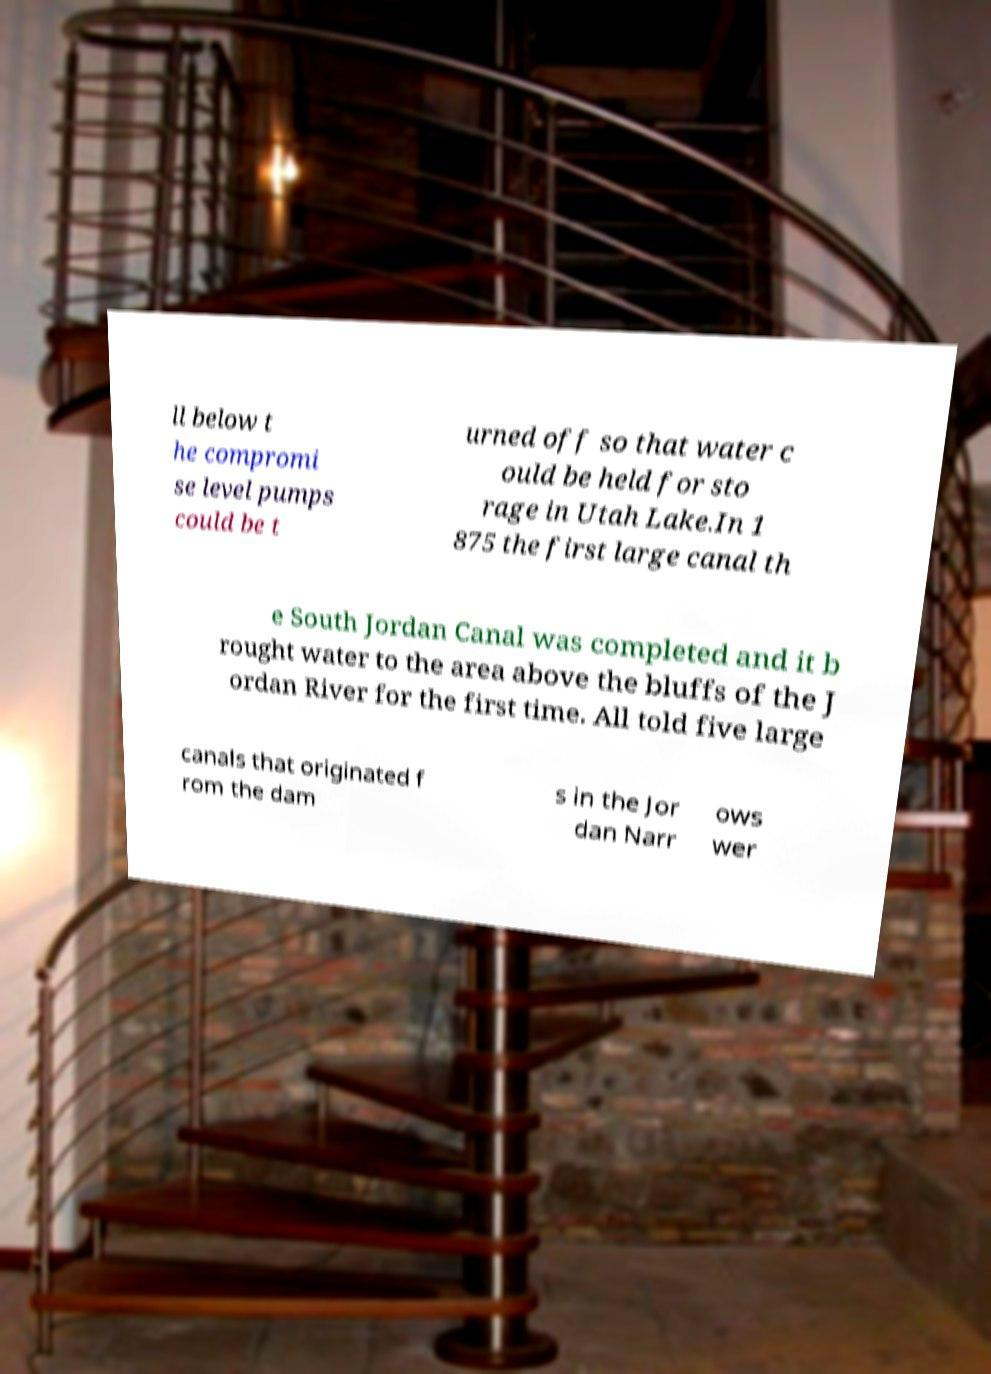For documentation purposes, I need the text within this image transcribed. Could you provide that? ll below t he compromi se level pumps could be t urned off so that water c ould be held for sto rage in Utah Lake.In 1 875 the first large canal th e South Jordan Canal was completed and it b rought water to the area above the bluffs of the J ordan River for the first time. All told five large canals that originated f rom the dam s in the Jor dan Narr ows wer 